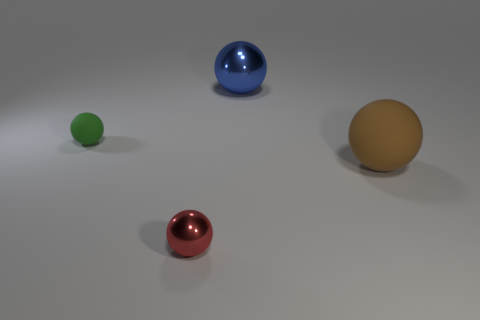There is a big ball that is made of the same material as the small green object; what color is it?
Your response must be concise. Brown. Are there more matte objects right of the big blue shiny ball than large blue balls in front of the small red sphere?
Provide a succinct answer. Yes. What color is the large matte thing that is the same shape as the tiny metal object?
Offer a terse response. Brown. Do the large shiny object and the rubber thing behind the large brown rubber object have the same shape?
Provide a succinct answer. Yes. There is a big metal ball; is its color the same as the rubber thing to the left of the blue object?
Offer a terse response. No. What material is the tiny object that is right of the small green matte sphere?
Keep it short and to the point. Metal. Is there another object that has the same color as the small metal thing?
Your response must be concise. No. What color is the other object that is the same size as the red object?
Provide a succinct answer. Green. What number of small things are either metallic objects or brown objects?
Your answer should be very brief. 1. Is the number of big matte things left of the big brown sphere the same as the number of blue objects that are left of the red sphere?
Make the answer very short. Yes. 